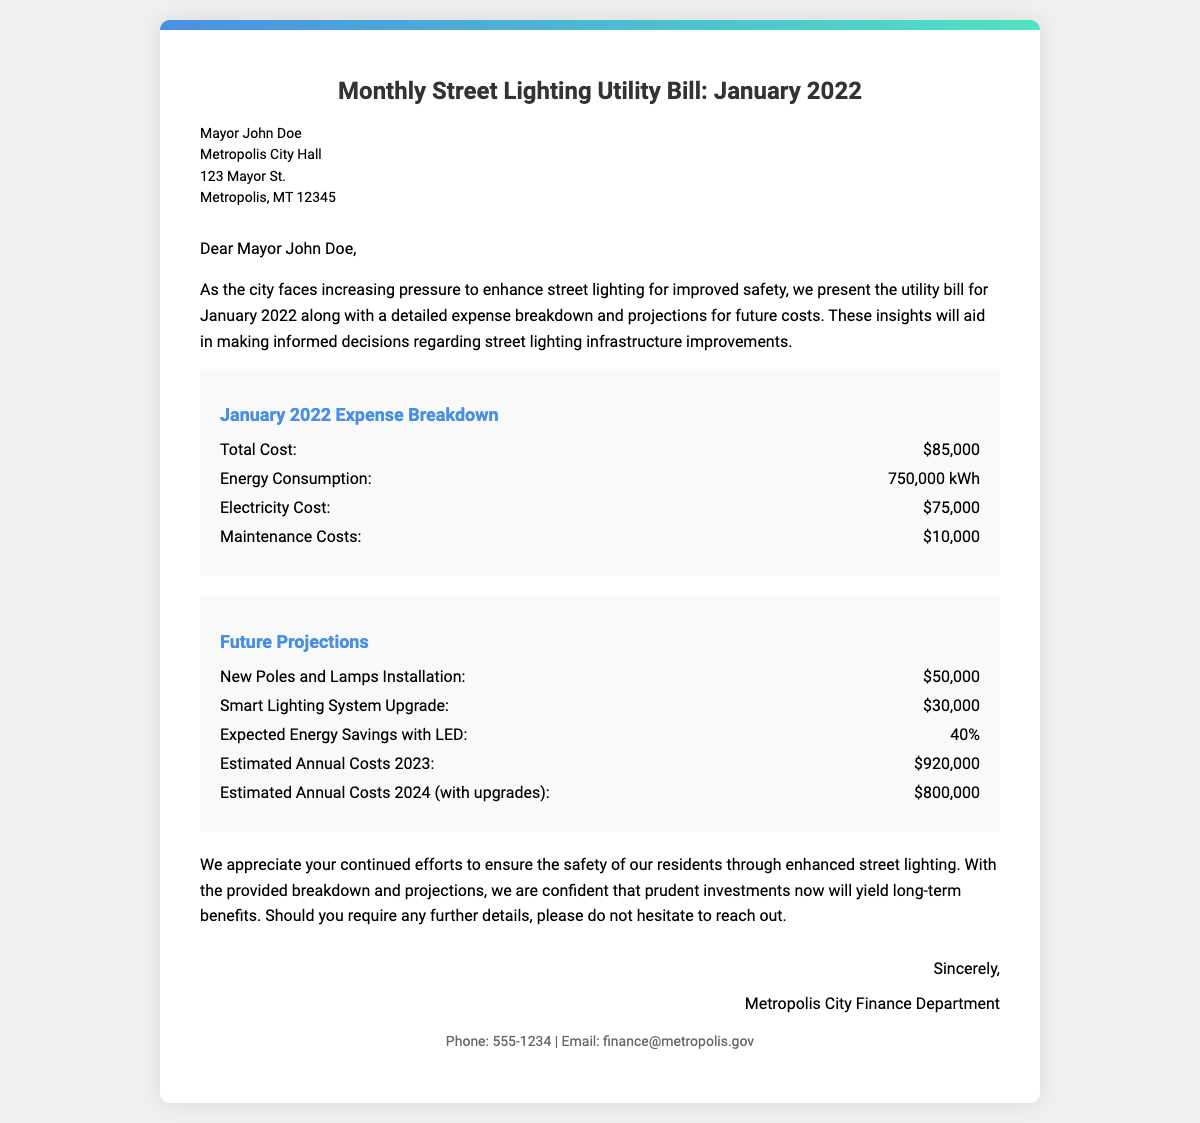what is the total cost for January 2022? The total cost for January 2022 is stated directly in the expense breakdown section of the document.
Answer: $85,000 how much did energy consumption amount to in January 2022? The document provides specific consumption data, listed in kilowatt-hours (kWh).
Answer: 750,000 kWh what were the maintenance costs for January 2022? The maintenance costs are clearly indicated in the expense breakdown of the document.
Answer: $10,000 what is the expected energy savings with LED installations? The document mentions a specific percentage related to energy savings expected from the upgrades to LED lighting.
Answer: 40% how much is projected for new poles and lamps installation? The projections detail future costs and specifically list amounts for different projects, which includes new poles and lamps installation.
Answer: $50,000 what are the estimated annual costs for 2024 with upgrades? The future projections provide specific figures for estimated annual costs, clearly outlining costs for 2023 and 2024.
Answer: $800,000 who is the document addressed to? The recipient of the document is identified at the top, and includes the name and title of the individual.
Answer: Mayor John Doe who signed off the document? The sign-off section states who is providing the information, indicating the department sending the bill.
Answer: Metropolis City Finance Department what are the projected costs for the Smart Lighting System Upgrade? The specific costs for different projected upgrades are outlined in the future projections section.
Answer: $30,000 